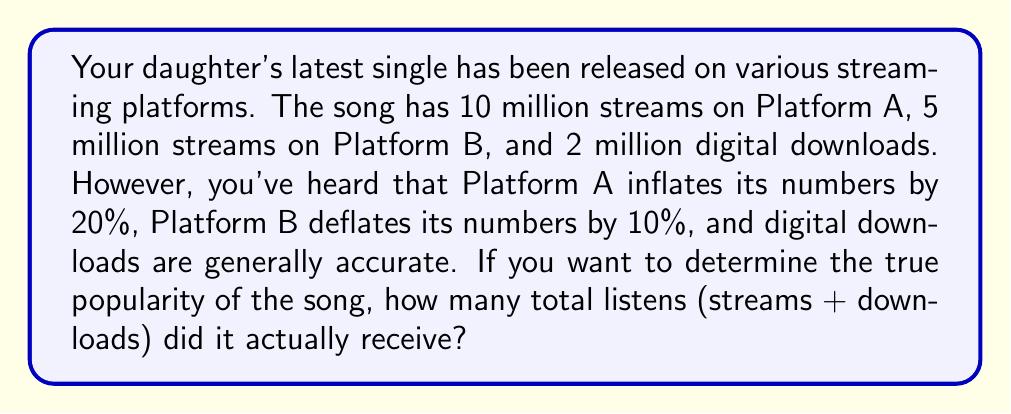Give your solution to this math problem. Let's approach this step-by-step:

1. Adjust Platform A streams:
   Platform A reports 10 million streams, but inflates by 20%.
   True streams = Reported streams ÷ (1 + Inflation rate)
   $$\text{True streams A} = \frac{10,000,000}{1.20} = 8,333,333.33$$

2. Adjust Platform B streams:
   Platform B reports 5 million streams, but deflates by 10%.
   True streams = Reported streams ÷ (1 - Deflation rate)
   $$\text{True streams B} = \frac{5,000,000}{0.90} = 5,555,555.56$$

3. Digital downloads:
   These are reported as accurate, so we use the given number: 2,000,000

4. Calculate total true listens:
   Sum of true streams from both platforms and digital downloads
   $$\text{Total true listens} = 8,333,333.33 + 5,555,555.56 + 2,000,000 = 15,888,888.89$$

5. Round to the nearest whole number:
   $$\text{Total true listens} = 15,888,889$$
Answer: 15,888,889 listens 